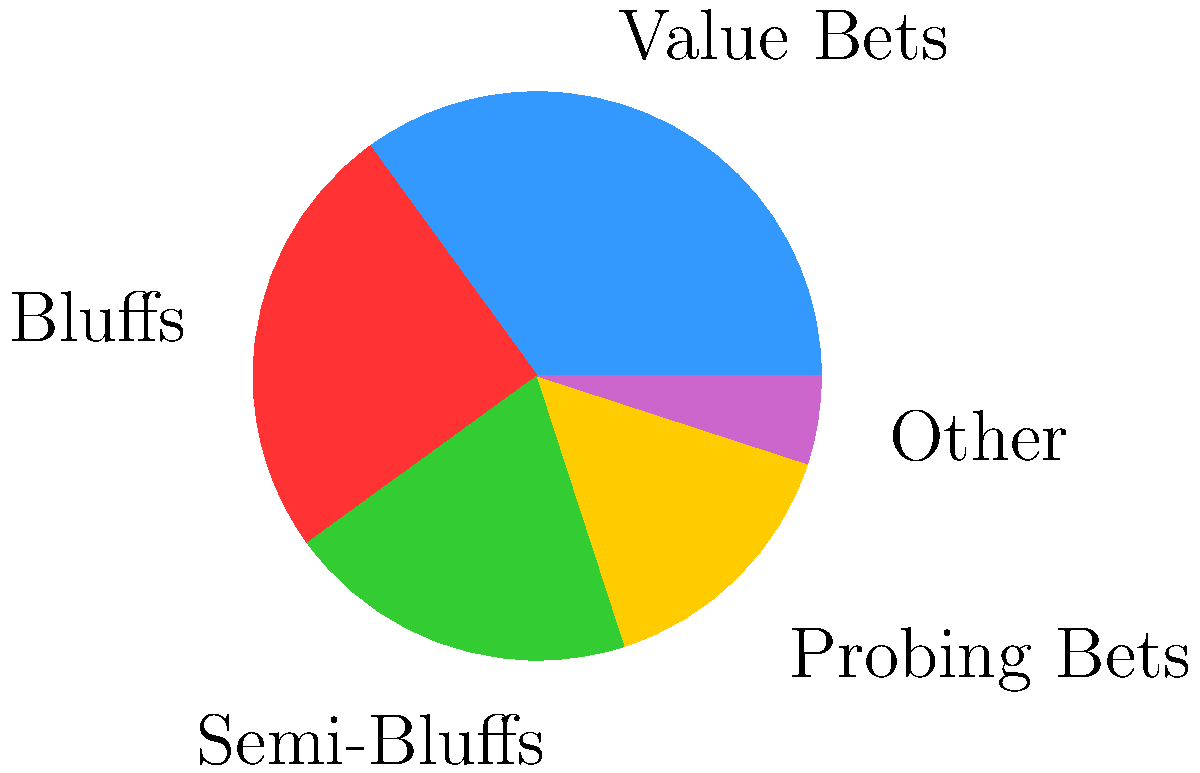As a poker coach analyzing betting patterns, you've collected data on a player's river betting tendencies. The pie chart represents the distribution of different bet types. If this player makes 200 river bets in total, how many of these bets are expected to be semi-bluffs? To solve this problem, we need to follow these steps:

1. Identify the percentage of semi-bluffs from the pie chart:
   The pie chart shows that semi-bluffs account for 20% of the player's river bets.

2. Calculate the number of semi-bluffs given 200 total river bets:
   Let $x$ be the number of semi-bluffs.
   We can set up the following equation:
   $\frac{x}{200} = \frac{20}{100}$

3. Solve for $x$:
   $x = 200 \times \frac{20}{100} = 40$

Therefore, out of 200 river bets, we expect 40 to be semi-bluffs.
Answer: 40 semi-bluffs 